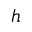<formula> <loc_0><loc_0><loc_500><loc_500>h</formula> 